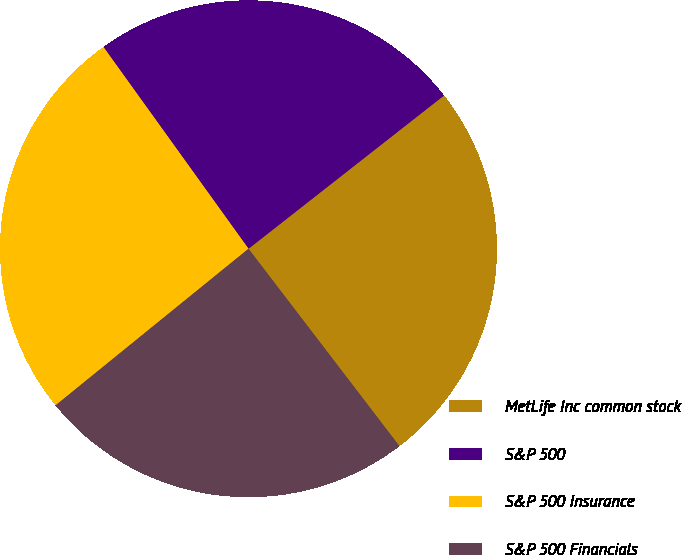Convert chart. <chart><loc_0><loc_0><loc_500><loc_500><pie_chart><fcel>MetLife Inc common stock<fcel>S&P 500<fcel>S&P 500 Insurance<fcel>S&P 500 Financials<nl><fcel>25.19%<fcel>24.34%<fcel>25.93%<fcel>24.54%<nl></chart> 